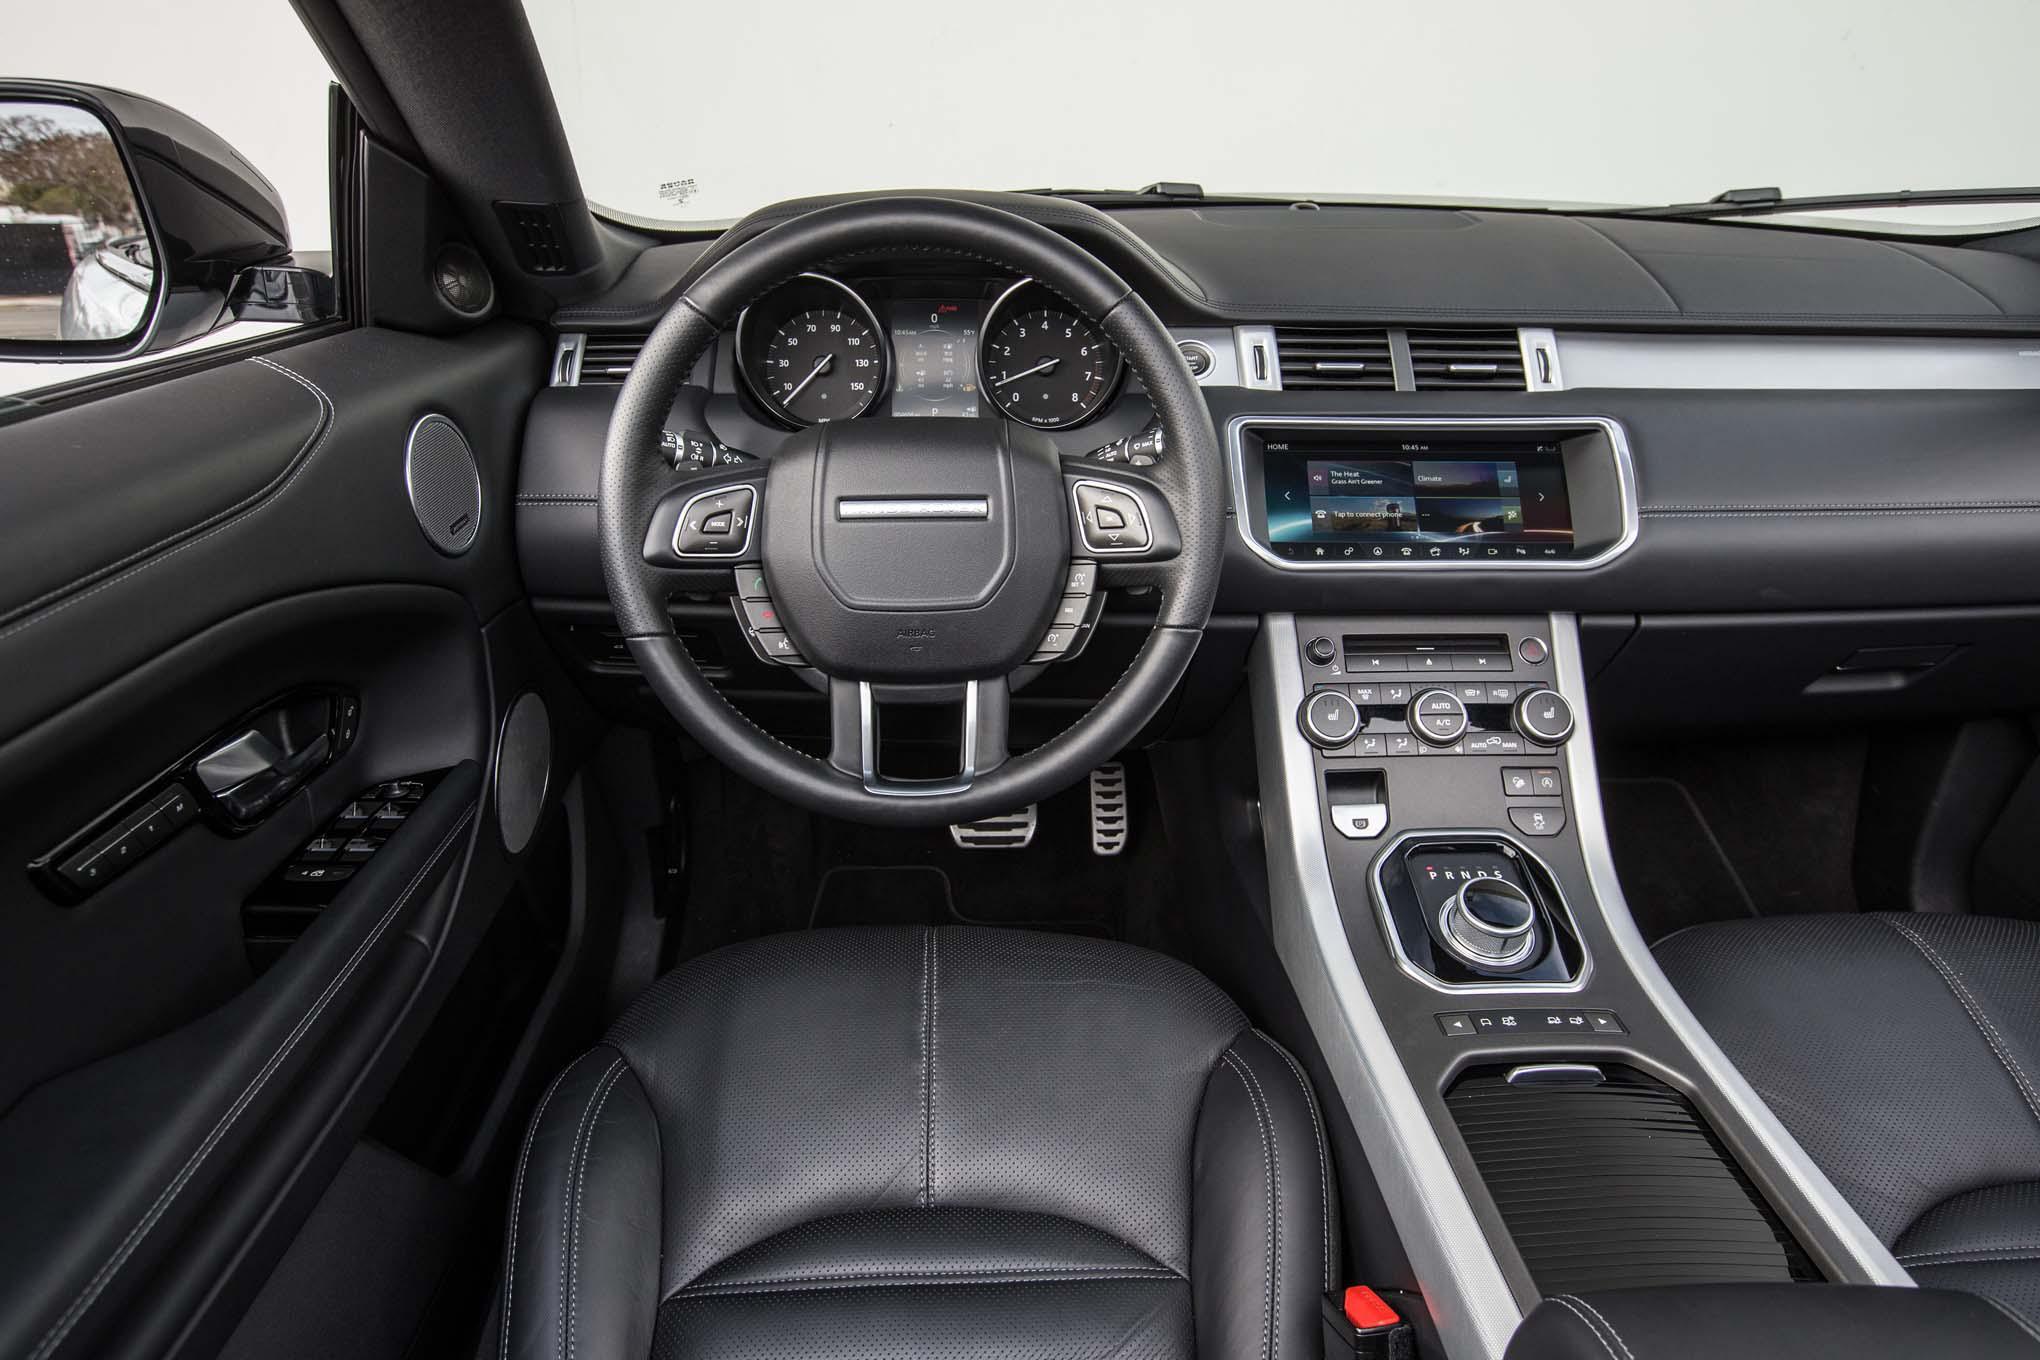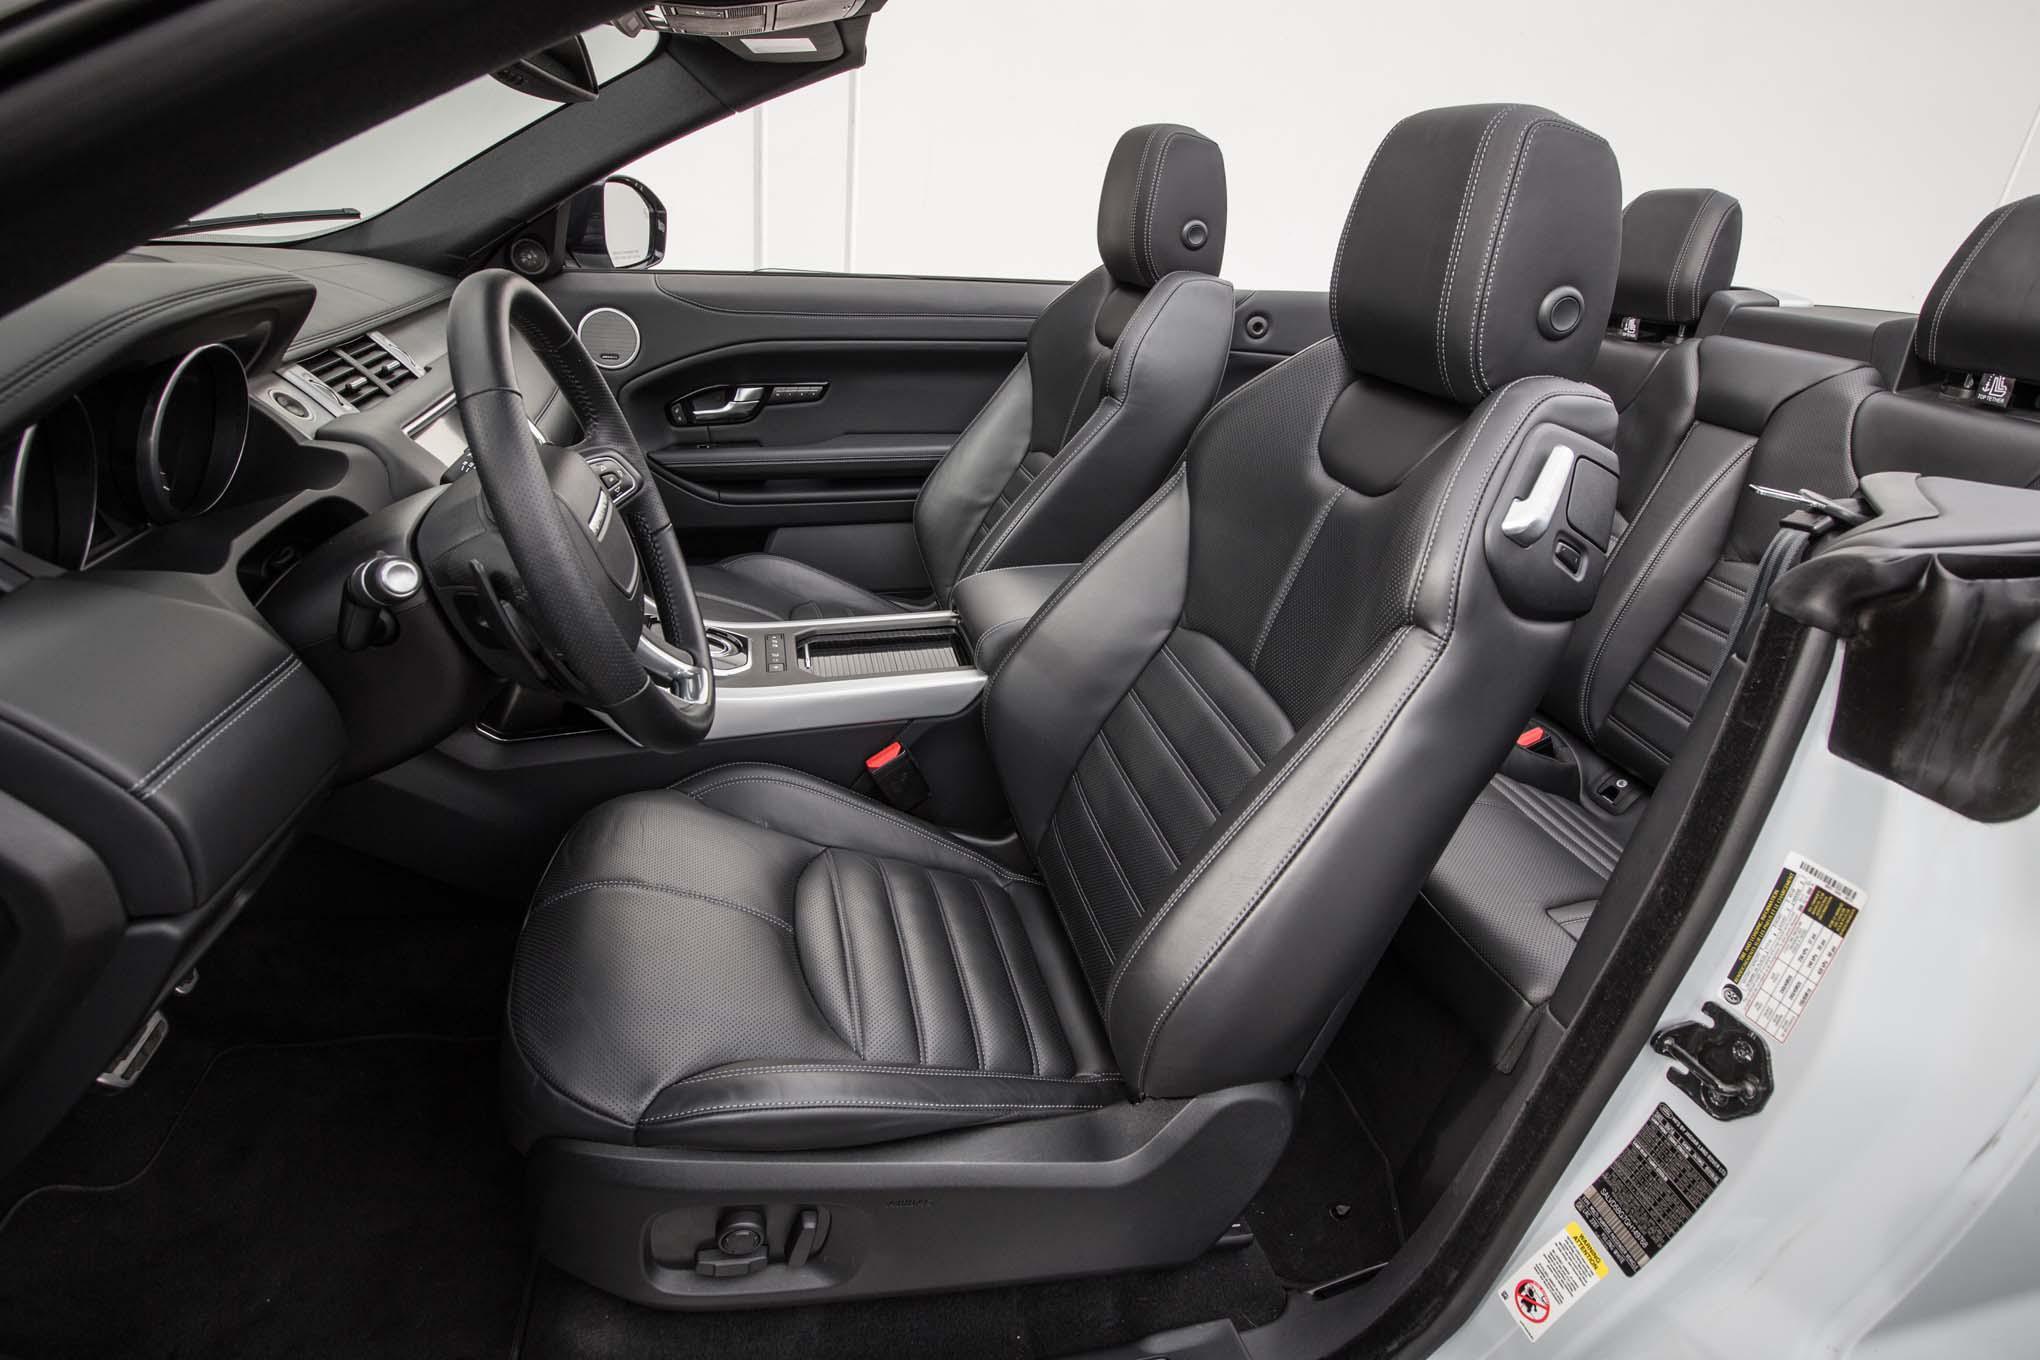The first image is the image on the left, the second image is the image on the right. Examine the images to the left and right. Is the description "The right image contains a white vehicle that is facing towards the right." accurate? Answer yes or no. No. The first image is the image on the left, the second image is the image on the right. For the images shown, is this caption "Each image shows a white Range Rover with its top covered, but one car has black rims while the other has silver rims." true? Answer yes or no. No. 